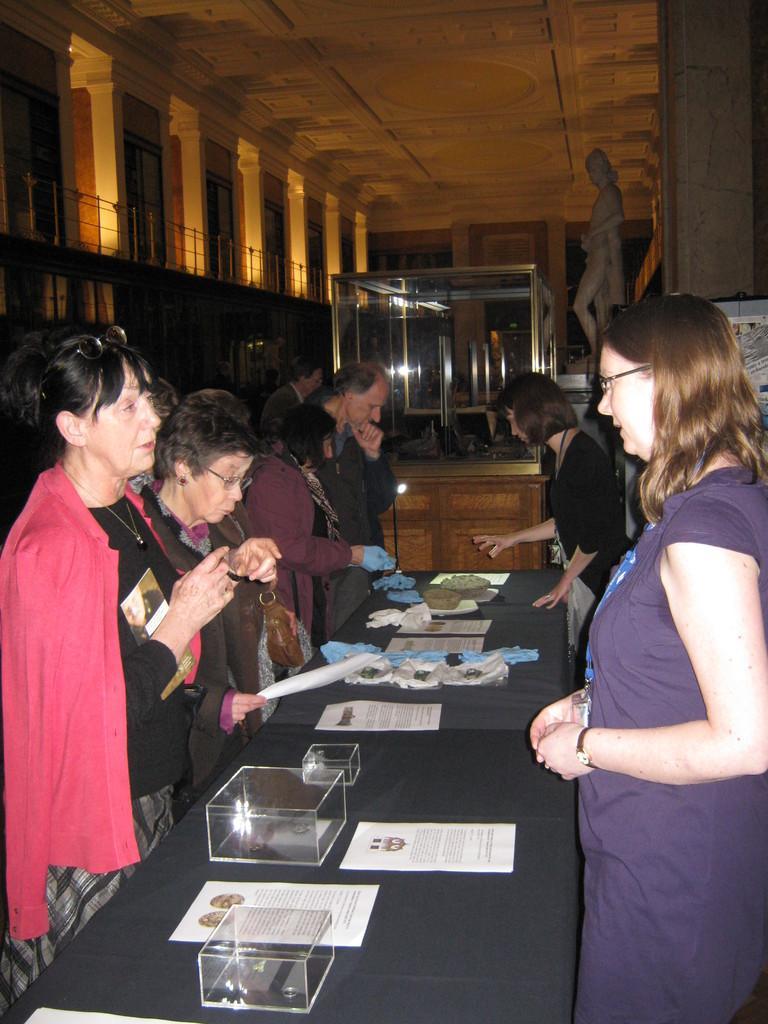Please provide a concise description of this image. At the bottom of the image there is a table with papers, glass boxes and some other items. There are few ladies standing. In the background there is a statue and also there is a big glass box on the wooden object. At the top of the image there are pillars and railing. 